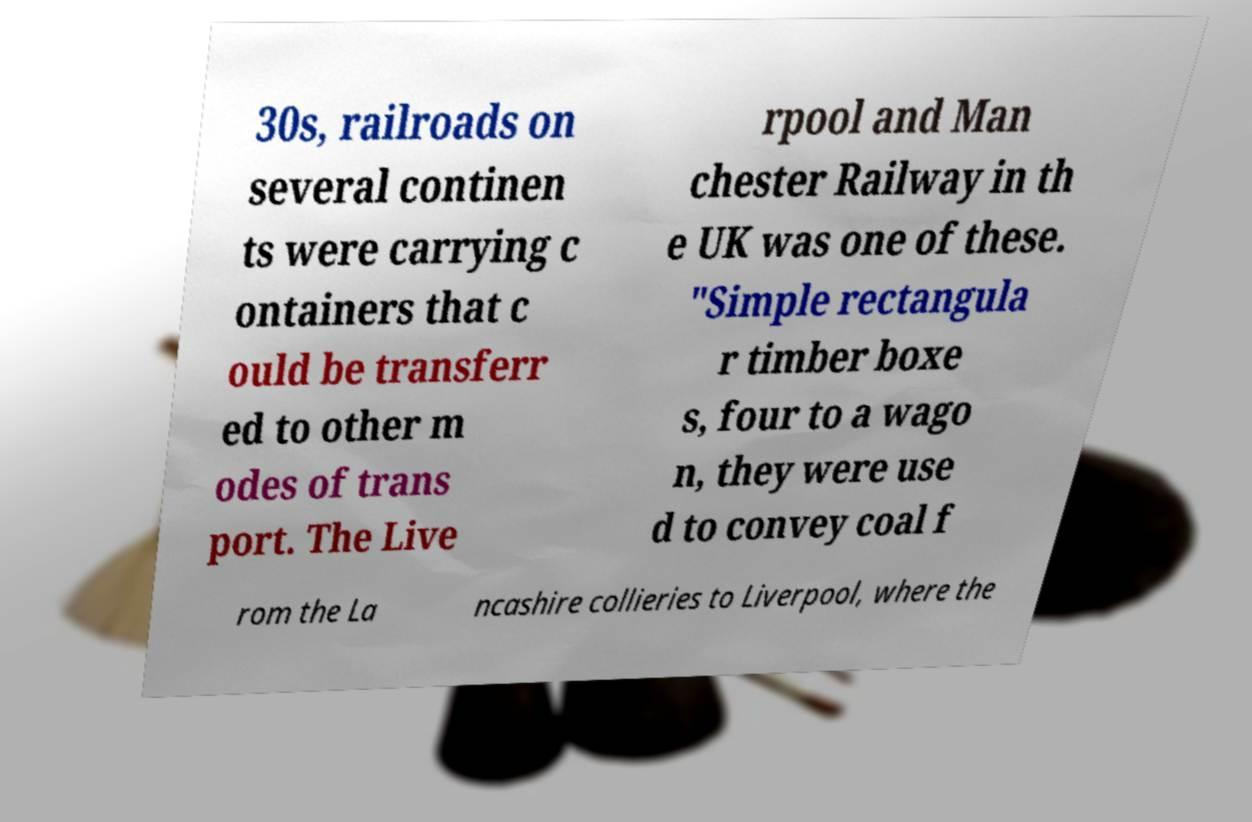Can you accurately transcribe the text from the provided image for me? 30s, railroads on several continen ts were carrying c ontainers that c ould be transferr ed to other m odes of trans port. The Live rpool and Man chester Railway in th e UK was one of these. "Simple rectangula r timber boxe s, four to a wago n, they were use d to convey coal f rom the La ncashire collieries to Liverpool, where the 